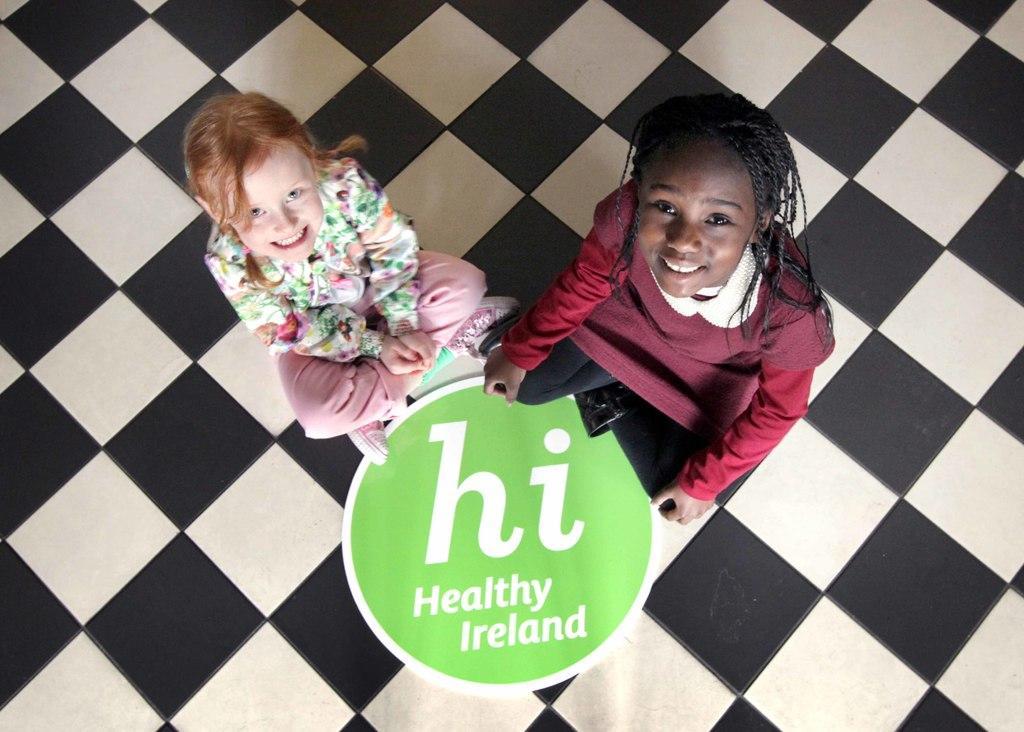Could you give a brief overview of what you see in this image? In this picture, we see two girls are sitting on the floor. They are smiling and they are posing for the photo. In front of them, we see a board in green color with text written as "HI HEALTHY IRELAND". In the background, we see the floor which, is in white and black color. 